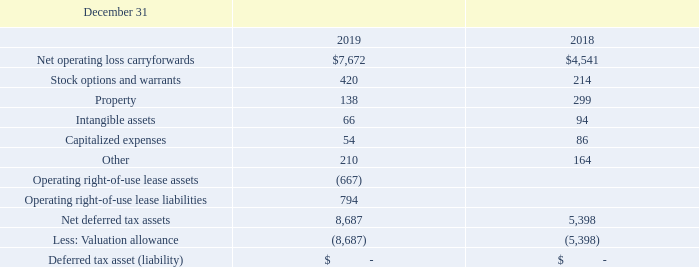NOTE 13. INCOME TAXES
We calculate our provision for federal and state income taxes based on current tax law. U.S. federal tax reform (Tax Act) was enacted on December 22, 2017, and has several key provisions impacting the accounting for and reporting of income taxes. The most significant provision reduced the U.S. corporate statutory tax rate from 35% to 21% beginning on January 1, 2018. We remeasured the applicable deferred tax assets and liabilities based on the rates at which they are expected to reverse. As a result, the gross deferred tax assets and liabilities were adjusted which resulted in an expense for income taxes of $7.1 million which was fully offset by a corresponding change to our valuation allowance in 2017. The Tax Act contains several base broadening provisions that became effective on January 1, 2018, that did not have a material impact on 2018 and 2019 earnings.
Deferred tax asset (liability) is comprised of the following (in thousands):
We have determined it is more likely than not that our deferred tax assets will not be realized. Accordingly, we have provided a valuation allowance for deferred tax assets.
What are the respective net operating loss carryforwards in 2018 and 2019?
Answer scale should be: thousand. $4,541, $7,672. What are the respective values of stock options and warrants in 2018 and 2019?
Answer scale should be: thousand. 214, 420. What are the respective property values in 2018 and 2019?
Answer scale should be: thousand. 299, 138. What is the average net operating loss carryforward in 2018 and 2019?
Answer scale should be: thousand. (7,672 + 4,541)/2 
Answer: 6106.5. What is the percentage change in net operating loss carryforward in 2018 and 2019?
Answer scale should be: percent. (7,672 - 4,541)/4,541 
Answer: 68.95. What is the percentage change in the stock options and warrants between 2018 and 2019?
Answer scale should be: percent. (420 - 214)/214 
Answer: 96.26. 